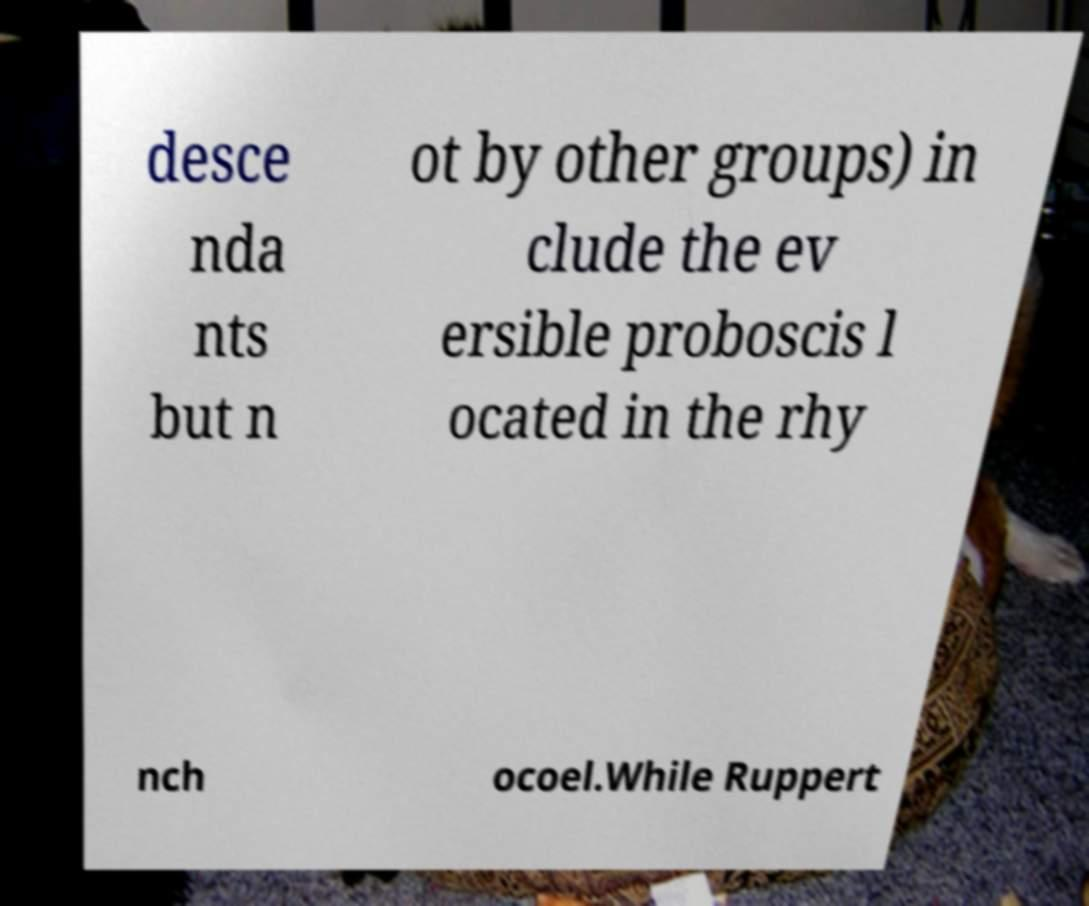Could you assist in decoding the text presented in this image and type it out clearly? desce nda nts but n ot by other groups) in clude the ev ersible proboscis l ocated in the rhy nch ocoel.While Ruppert 